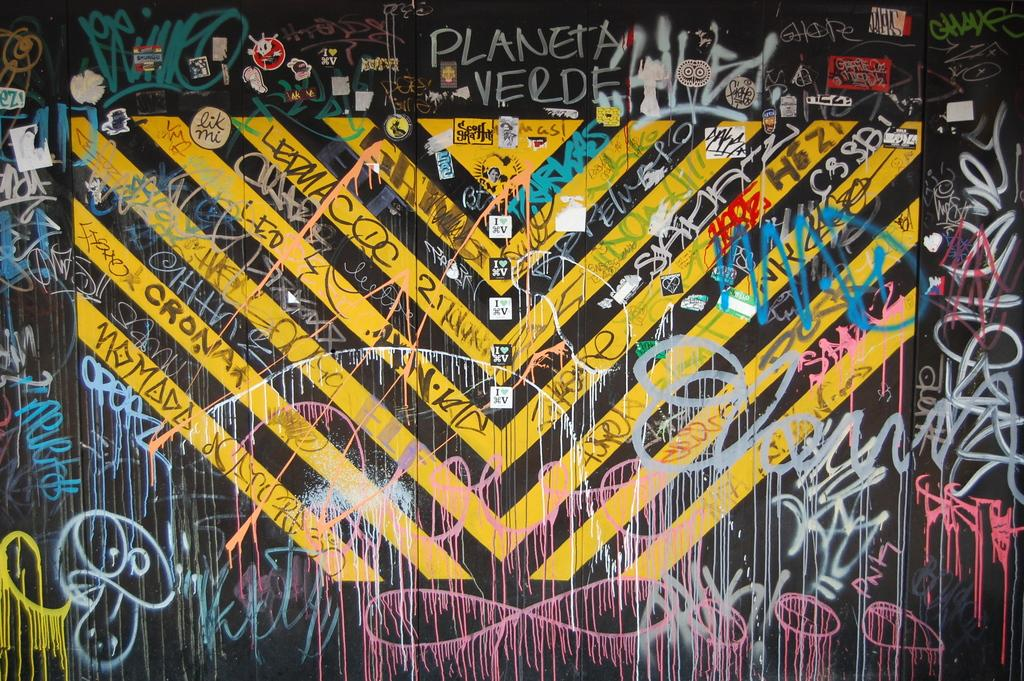Provide a one-sentence caption for the provided image. A bunch of grafiti on a wall on top saying Planeta verde. 